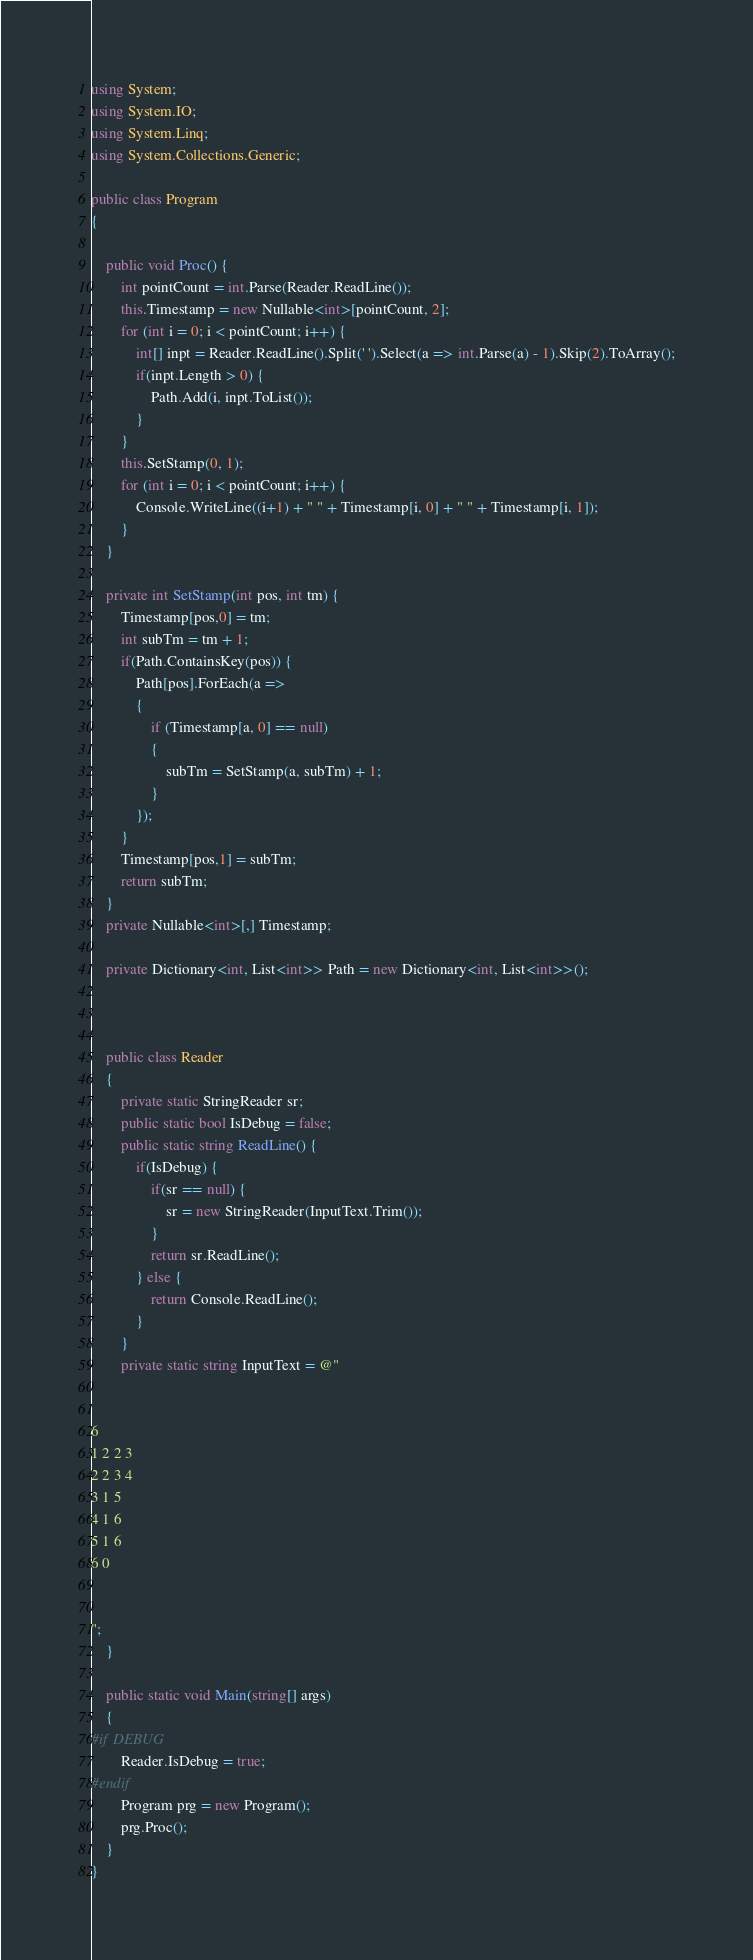Convert code to text. <code><loc_0><loc_0><loc_500><loc_500><_C#_>using System;
using System.IO;
using System.Linq;
using System.Collections.Generic;

public class Program
{

    public void Proc() {
        int pointCount = int.Parse(Reader.ReadLine());
        this.Timestamp = new Nullable<int>[pointCount, 2];
        for (int i = 0; i < pointCount; i++) {
            int[] inpt = Reader.ReadLine().Split(' ').Select(a => int.Parse(a) - 1).Skip(2).ToArray();
            if(inpt.Length > 0) {
                Path.Add(i, inpt.ToList());
            }
        }
        this.SetStamp(0, 1);
        for (int i = 0; i < pointCount; i++) {
            Console.WriteLine((i+1) + " " + Timestamp[i, 0] + " " + Timestamp[i, 1]);
        }
    }

    private int SetStamp(int pos, int tm) {
        Timestamp[pos,0] = tm;
        int subTm = tm + 1;
        if(Path.ContainsKey(pos)) {
            Path[pos].ForEach(a =>
            {
                if (Timestamp[a, 0] == null)
                {
                    subTm = SetStamp(a, subTm) + 1;
                }
            });
        }
        Timestamp[pos,1] = subTm;
        return subTm;
    }
    private Nullable<int>[,] Timestamp;

    private Dictionary<int, List<int>> Path = new Dictionary<int, List<int>>();



    public class Reader
    {
        private static StringReader sr;
        public static bool IsDebug = false;
        public static string ReadLine() {
            if(IsDebug) {
                if(sr == null) {
                    sr = new StringReader(InputText.Trim());
                }
                return sr.ReadLine();
            } else {
                return Console.ReadLine();
            }
        }
        private static string InputText = @"


6
1 2 2 3
2 2 3 4
3 1 5
4 1 6
5 1 6
6 0


";
    }

    public static void Main(string[] args)
    {
#if DEBUG
        Reader.IsDebug = true;
#endif
        Program prg = new Program();
        prg.Proc();
	}
}</code> 